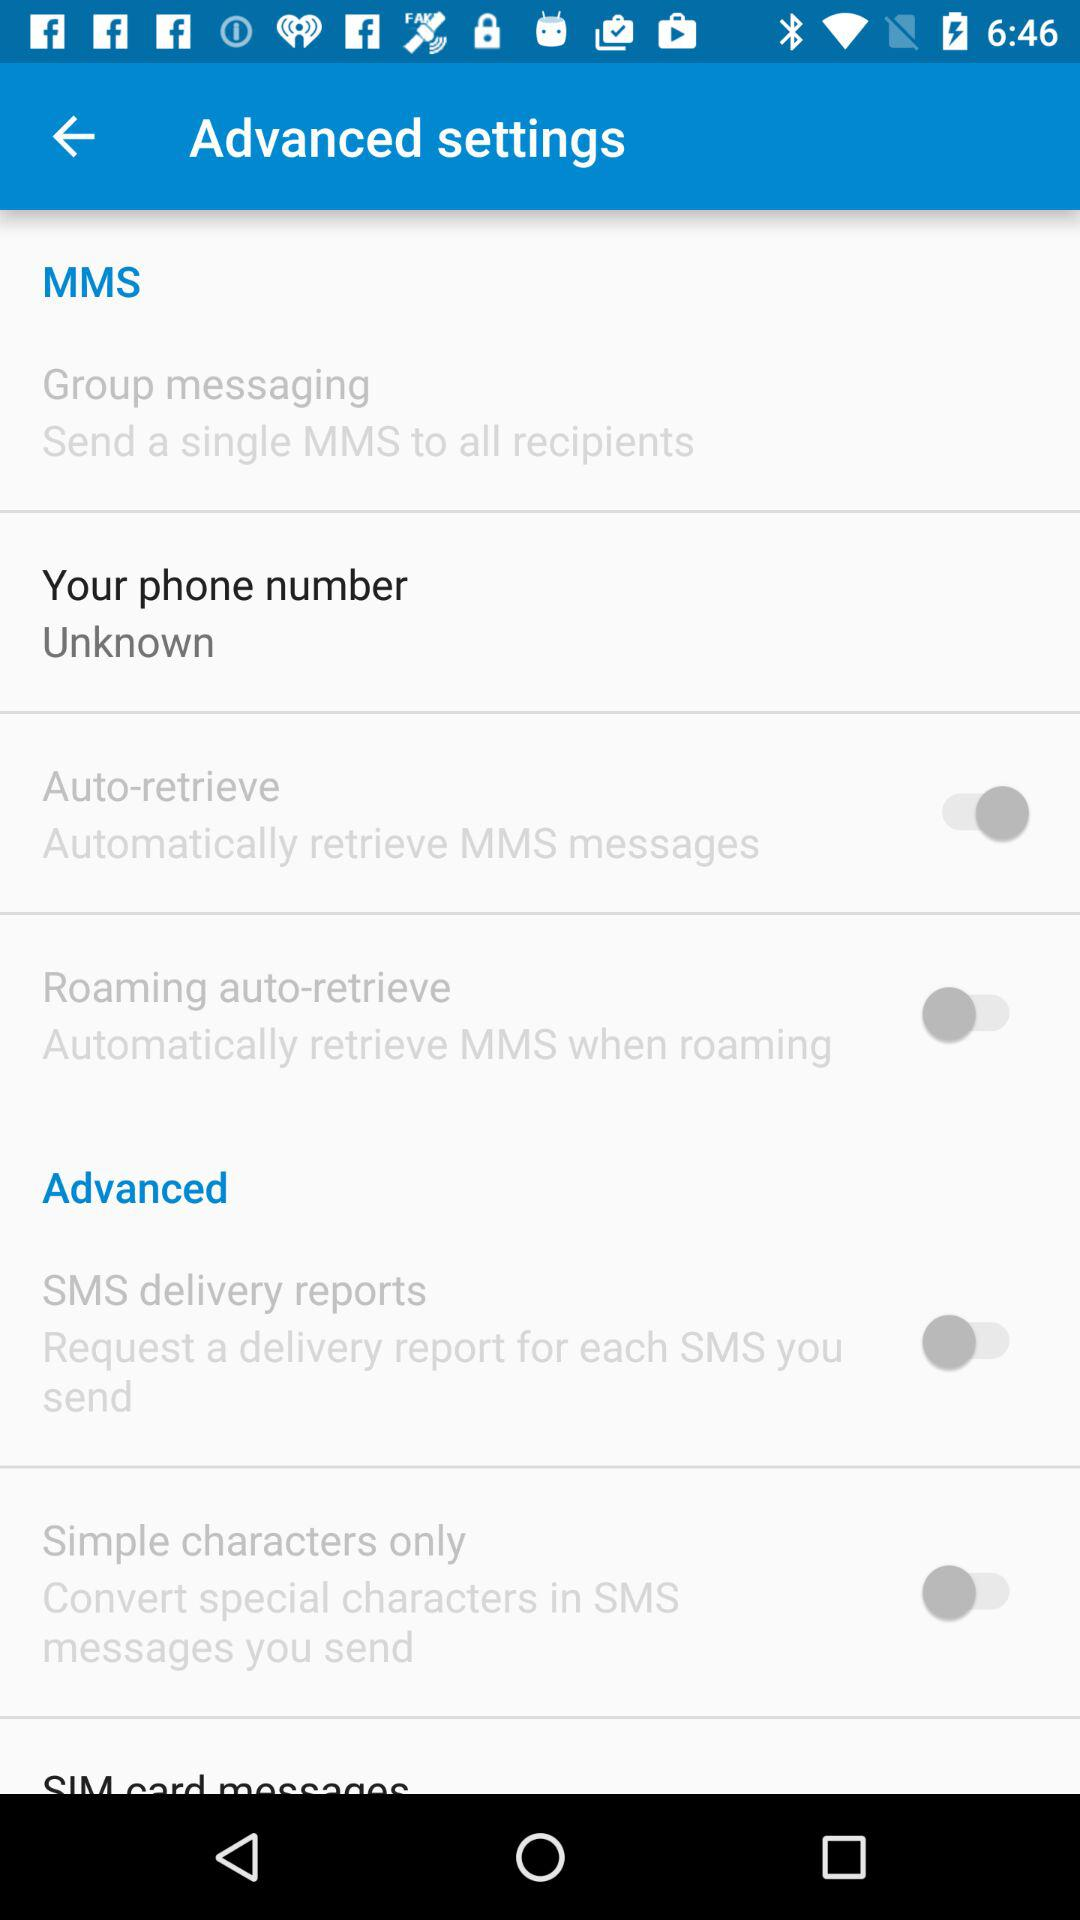What is the status of the "Auto-retrieve"? The status is "on". 